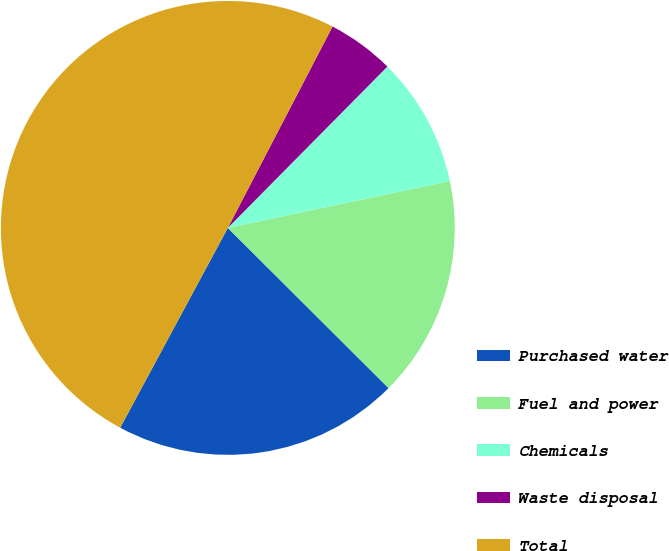Convert chart to OTSL. <chart><loc_0><loc_0><loc_500><loc_500><pie_chart><fcel>Purchased water<fcel>Fuel and power<fcel>Chemicals<fcel>Waste disposal<fcel>Total<nl><fcel>20.39%<fcel>15.79%<fcel>9.27%<fcel>4.78%<fcel>49.77%<nl></chart> 